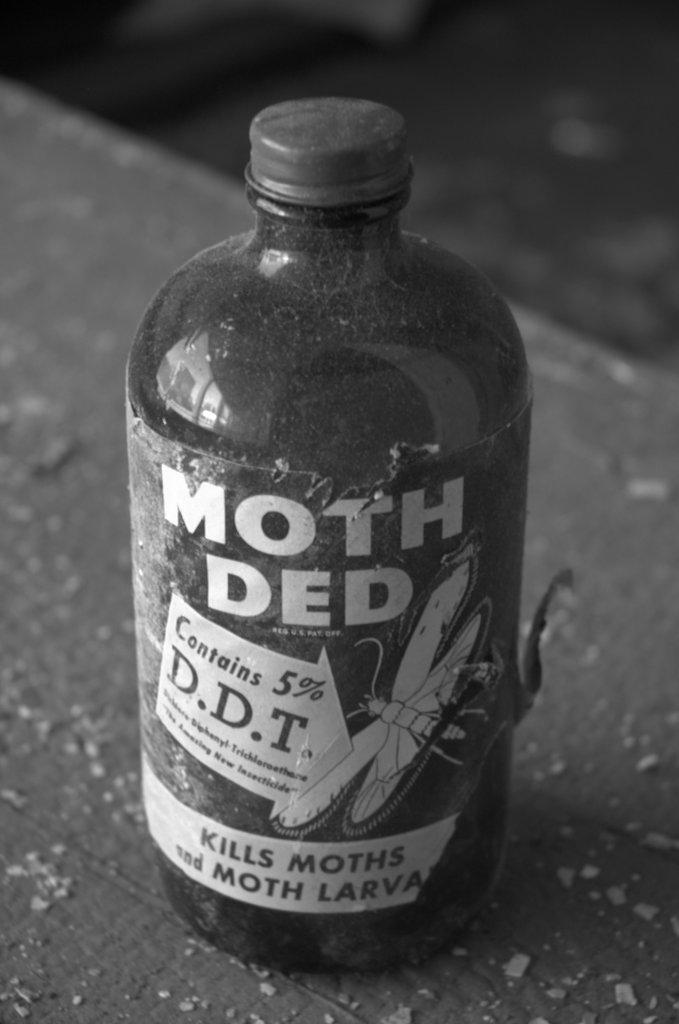<image>
Relay a brief, clear account of the picture shown. A glass bottle of Moth Ded sits on a wooden table. 